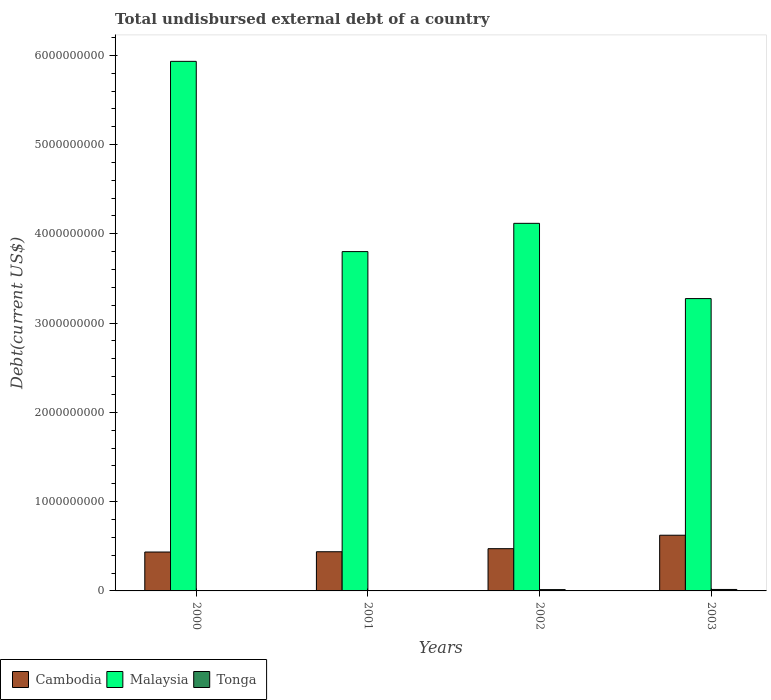How many different coloured bars are there?
Your answer should be compact. 3. Are the number of bars on each tick of the X-axis equal?
Keep it short and to the point. Yes. How many bars are there on the 4th tick from the right?
Ensure brevity in your answer.  3. What is the label of the 1st group of bars from the left?
Provide a short and direct response. 2000. In how many cases, is the number of bars for a given year not equal to the number of legend labels?
Provide a short and direct response. 0. What is the total undisbursed external debt in Tonga in 2000?
Offer a very short reply. 1.98e+06. Across all years, what is the maximum total undisbursed external debt in Cambodia?
Give a very brief answer. 6.24e+08. Across all years, what is the minimum total undisbursed external debt in Cambodia?
Your answer should be compact. 4.36e+08. In which year was the total undisbursed external debt in Tonga minimum?
Provide a short and direct response. 2000. What is the total total undisbursed external debt in Malaysia in the graph?
Your answer should be very brief. 1.71e+1. What is the difference between the total undisbursed external debt in Tonga in 2000 and that in 2002?
Provide a short and direct response. -1.28e+07. What is the difference between the total undisbursed external debt in Malaysia in 2003 and the total undisbursed external debt in Cambodia in 2001?
Your response must be concise. 2.84e+09. What is the average total undisbursed external debt in Malaysia per year?
Keep it short and to the point. 4.28e+09. In the year 2000, what is the difference between the total undisbursed external debt in Cambodia and total undisbursed external debt in Malaysia?
Provide a succinct answer. -5.50e+09. In how many years, is the total undisbursed external debt in Malaysia greater than 1200000000 US$?
Give a very brief answer. 4. What is the ratio of the total undisbursed external debt in Cambodia in 2001 to that in 2003?
Provide a short and direct response. 0.7. Is the difference between the total undisbursed external debt in Cambodia in 2001 and 2002 greater than the difference between the total undisbursed external debt in Malaysia in 2001 and 2002?
Give a very brief answer. Yes. What is the difference between the highest and the second highest total undisbursed external debt in Cambodia?
Your answer should be compact. 1.51e+08. What is the difference between the highest and the lowest total undisbursed external debt in Tonga?
Your answer should be very brief. 1.43e+07. Is the sum of the total undisbursed external debt in Malaysia in 2002 and 2003 greater than the maximum total undisbursed external debt in Tonga across all years?
Offer a very short reply. Yes. What does the 2nd bar from the left in 2001 represents?
Offer a very short reply. Malaysia. What does the 1st bar from the right in 2002 represents?
Make the answer very short. Tonga. How many bars are there?
Give a very brief answer. 12. Are all the bars in the graph horizontal?
Offer a terse response. No. Does the graph contain grids?
Keep it short and to the point. No. How many legend labels are there?
Offer a terse response. 3. How are the legend labels stacked?
Your response must be concise. Horizontal. What is the title of the graph?
Keep it short and to the point. Total undisbursed external debt of a country. Does "Faeroe Islands" appear as one of the legend labels in the graph?
Provide a succinct answer. No. What is the label or title of the Y-axis?
Offer a very short reply. Debt(current US$). What is the Debt(current US$) of Cambodia in 2000?
Your answer should be compact. 4.36e+08. What is the Debt(current US$) of Malaysia in 2000?
Provide a short and direct response. 5.93e+09. What is the Debt(current US$) in Tonga in 2000?
Offer a terse response. 1.98e+06. What is the Debt(current US$) in Cambodia in 2001?
Your answer should be very brief. 4.39e+08. What is the Debt(current US$) of Malaysia in 2001?
Keep it short and to the point. 3.80e+09. What is the Debt(current US$) of Tonga in 2001?
Offer a terse response. 3.44e+06. What is the Debt(current US$) in Cambodia in 2002?
Give a very brief answer. 4.73e+08. What is the Debt(current US$) in Malaysia in 2002?
Provide a short and direct response. 4.12e+09. What is the Debt(current US$) in Tonga in 2002?
Your answer should be compact. 1.48e+07. What is the Debt(current US$) of Cambodia in 2003?
Your answer should be compact. 6.24e+08. What is the Debt(current US$) in Malaysia in 2003?
Make the answer very short. 3.27e+09. What is the Debt(current US$) of Tonga in 2003?
Make the answer very short. 1.63e+07. Across all years, what is the maximum Debt(current US$) in Cambodia?
Your response must be concise. 6.24e+08. Across all years, what is the maximum Debt(current US$) in Malaysia?
Make the answer very short. 5.93e+09. Across all years, what is the maximum Debt(current US$) of Tonga?
Offer a very short reply. 1.63e+07. Across all years, what is the minimum Debt(current US$) in Cambodia?
Keep it short and to the point. 4.36e+08. Across all years, what is the minimum Debt(current US$) of Malaysia?
Provide a succinct answer. 3.27e+09. Across all years, what is the minimum Debt(current US$) in Tonga?
Your response must be concise. 1.98e+06. What is the total Debt(current US$) of Cambodia in the graph?
Your answer should be compact. 1.97e+09. What is the total Debt(current US$) in Malaysia in the graph?
Provide a short and direct response. 1.71e+1. What is the total Debt(current US$) in Tonga in the graph?
Make the answer very short. 3.65e+07. What is the difference between the Debt(current US$) in Cambodia in 2000 and that in 2001?
Give a very brief answer. -3.03e+06. What is the difference between the Debt(current US$) in Malaysia in 2000 and that in 2001?
Keep it short and to the point. 2.13e+09. What is the difference between the Debt(current US$) of Tonga in 2000 and that in 2001?
Keep it short and to the point. -1.46e+06. What is the difference between the Debt(current US$) in Cambodia in 2000 and that in 2002?
Your answer should be compact. -3.74e+07. What is the difference between the Debt(current US$) in Malaysia in 2000 and that in 2002?
Your response must be concise. 1.81e+09. What is the difference between the Debt(current US$) of Tonga in 2000 and that in 2002?
Offer a terse response. -1.28e+07. What is the difference between the Debt(current US$) in Cambodia in 2000 and that in 2003?
Provide a succinct answer. -1.88e+08. What is the difference between the Debt(current US$) in Malaysia in 2000 and that in 2003?
Keep it short and to the point. 2.66e+09. What is the difference between the Debt(current US$) of Tonga in 2000 and that in 2003?
Your answer should be compact. -1.43e+07. What is the difference between the Debt(current US$) of Cambodia in 2001 and that in 2002?
Make the answer very short. -3.44e+07. What is the difference between the Debt(current US$) in Malaysia in 2001 and that in 2002?
Your answer should be compact. -3.17e+08. What is the difference between the Debt(current US$) in Tonga in 2001 and that in 2002?
Your response must be concise. -1.13e+07. What is the difference between the Debt(current US$) of Cambodia in 2001 and that in 2003?
Give a very brief answer. -1.85e+08. What is the difference between the Debt(current US$) of Malaysia in 2001 and that in 2003?
Make the answer very short. 5.26e+08. What is the difference between the Debt(current US$) of Tonga in 2001 and that in 2003?
Provide a succinct answer. -1.29e+07. What is the difference between the Debt(current US$) of Cambodia in 2002 and that in 2003?
Offer a terse response. -1.51e+08. What is the difference between the Debt(current US$) of Malaysia in 2002 and that in 2003?
Offer a very short reply. 8.43e+08. What is the difference between the Debt(current US$) of Tonga in 2002 and that in 2003?
Make the answer very short. -1.53e+06. What is the difference between the Debt(current US$) of Cambodia in 2000 and the Debt(current US$) of Malaysia in 2001?
Provide a short and direct response. -3.37e+09. What is the difference between the Debt(current US$) of Cambodia in 2000 and the Debt(current US$) of Tonga in 2001?
Your response must be concise. 4.32e+08. What is the difference between the Debt(current US$) in Malaysia in 2000 and the Debt(current US$) in Tonga in 2001?
Keep it short and to the point. 5.93e+09. What is the difference between the Debt(current US$) in Cambodia in 2000 and the Debt(current US$) in Malaysia in 2002?
Ensure brevity in your answer.  -3.68e+09. What is the difference between the Debt(current US$) in Cambodia in 2000 and the Debt(current US$) in Tonga in 2002?
Your response must be concise. 4.21e+08. What is the difference between the Debt(current US$) in Malaysia in 2000 and the Debt(current US$) in Tonga in 2002?
Offer a terse response. 5.92e+09. What is the difference between the Debt(current US$) in Cambodia in 2000 and the Debt(current US$) in Malaysia in 2003?
Provide a succinct answer. -2.84e+09. What is the difference between the Debt(current US$) of Cambodia in 2000 and the Debt(current US$) of Tonga in 2003?
Your answer should be compact. 4.20e+08. What is the difference between the Debt(current US$) in Malaysia in 2000 and the Debt(current US$) in Tonga in 2003?
Provide a short and direct response. 5.92e+09. What is the difference between the Debt(current US$) in Cambodia in 2001 and the Debt(current US$) in Malaysia in 2002?
Give a very brief answer. -3.68e+09. What is the difference between the Debt(current US$) of Cambodia in 2001 and the Debt(current US$) of Tonga in 2002?
Give a very brief answer. 4.24e+08. What is the difference between the Debt(current US$) of Malaysia in 2001 and the Debt(current US$) of Tonga in 2002?
Make the answer very short. 3.79e+09. What is the difference between the Debt(current US$) of Cambodia in 2001 and the Debt(current US$) of Malaysia in 2003?
Provide a succinct answer. -2.84e+09. What is the difference between the Debt(current US$) in Cambodia in 2001 and the Debt(current US$) in Tonga in 2003?
Offer a very short reply. 4.23e+08. What is the difference between the Debt(current US$) of Malaysia in 2001 and the Debt(current US$) of Tonga in 2003?
Make the answer very short. 3.78e+09. What is the difference between the Debt(current US$) in Cambodia in 2002 and the Debt(current US$) in Malaysia in 2003?
Your answer should be very brief. -2.80e+09. What is the difference between the Debt(current US$) of Cambodia in 2002 and the Debt(current US$) of Tonga in 2003?
Offer a terse response. 4.57e+08. What is the difference between the Debt(current US$) in Malaysia in 2002 and the Debt(current US$) in Tonga in 2003?
Provide a succinct answer. 4.10e+09. What is the average Debt(current US$) of Cambodia per year?
Offer a very short reply. 4.93e+08. What is the average Debt(current US$) of Malaysia per year?
Make the answer very short. 4.28e+09. What is the average Debt(current US$) in Tonga per year?
Keep it short and to the point. 9.12e+06. In the year 2000, what is the difference between the Debt(current US$) of Cambodia and Debt(current US$) of Malaysia?
Ensure brevity in your answer.  -5.50e+09. In the year 2000, what is the difference between the Debt(current US$) in Cambodia and Debt(current US$) in Tonga?
Offer a very short reply. 4.34e+08. In the year 2000, what is the difference between the Debt(current US$) in Malaysia and Debt(current US$) in Tonga?
Your answer should be compact. 5.93e+09. In the year 2001, what is the difference between the Debt(current US$) in Cambodia and Debt(current US$) in Malaysia?
Offer a terse response. -3.36e+09. In the year 2001, what is the difference between the Debt(current US$) of Cambodia and Debt(current US$) of Tonga?
Your answer should be compact. 4.35e+08. In the year 2001, what is the difference between the Debt(current US$) in Malaysia and Debt(current US$) in Tonga?
Make the answer very short. 3.80e+09. In the year 2002, what is the difference between the Debt(current US$) of Cambodia and Debt(current US$) of Malaysia?
Give a very brief answer. -3.64e+09. In the year 2002, what is the difference between the Debt(current US$) of Cambodia and Debt(current US$) of Tonga?
Provide a succinct answer. 4.58e+08. In the year 2002, what is the difference between the Debt(current US$) of Malaysia and Debt(current US$) of Tonga?
Your answer should be very brief. 4.10e+09. In the year 2003, what is the difference between the Debt(current US$) of Cambodia and Debt(current US$) of Malaysia?
Offer a terse response. -2.65e+09. In the year 2003, what is the difference between the Debt(current US$) in Cambodia and Debt(current US$) in Tonga?
Your response must be concise. 6.08e+08. In the year 2003, what is the difference between the Debt(current US$) of Malaysia and Debt(current US$) of Tonga?
Your response must be concise. 3.26e+09. What is the ratio of the Debt(current US$) of Cambodia in 2000 to that in 2001?
Provide a short and direct response. 0.99. What is the ratio of the Debt(current US$) in Malaysia in 2000 to that in 2001?
Keep it short and to the point. 1.56. What is the ratio of the Debt(current US$) in Tonga in 2000 to that in 2001?
Your response must be concise. 0.57. What is the ratio of the Debt(current US$) in Cambodia in 2000 to that in 2002?
Your response must be concise. 0.92. What is the ratio of the Debt(current US$) in Malaysia in 2000 to that in 2002?
Your answer should be very brief. 1.44. What is the ratio of the Debt(current US$) in Tonga in 2000 to that in 2002?
Give a very brief answer. 0.13. What is the ratio of the Debt(current US$) of Cambodia in 2000 to that in 2003?
Ensure brevity in your answer.  0.7. What is the ratio of the Debt(current US$) of Malaysia in 2000 to that in 2003?
Your answer should be very brief. 1.81. What is the ratio of the Debt(current US$) of Tonga in 2000 to that in 2003?
Your answer should be very brief. 0.12. What is the ratio of the Debt(current US$) of Cambodia in 2001 to that in 2002?
Ensure brevity in your answer.  0.93. What is the ratio of the Debt(current US$) in Malaysia in 2001 to that in 2002?
Offer a very short reply. 0.92. What is the ratio of the Debt(current US$) of Tonga in 2001 to that in 2002?
Your response must be concise. 0.23. What is the ratio of the Debt(current US$) of Cambodia in 2001 to that in 2003?
Ensure brevity in your answer.  0.7. What is the ratio of the Debt(current US$) of Malaysia in 2001 to that in 2003?
Your answer should be very brief. 1.16. What is the ratio of the Debt(current US$) of Tonga in 2001 to that in 2003?
Ensure brevity in your answer.  0.21. What is the ratio of the Debt(current US$) of Cambodia in 2002 to that in 2003?
Keep it short and to the point. 0.76. What is the ratio of the Debt(current US$) in Malaysia in 2002 to that in 2003?
Offer a very short reply. 1.26. What is the ratio of the Debt(current US$) in Tonga in 2002 to that in 2003?
Provide a short and direct response. 0.91. What is the difference between the highest and the second highest Debt(current US$) in Cambodia?
Make the answer very short. 1.51e+08. What is the difference between the highest and the second highest Debt(current US$) of Malaysia?
Offer a terse response. 1.81e+09. What is the difference between the highest and the second highest Debt(current US$) in Tonga?
Give a very brief answer. 1.53e+06. What is the difference between the highest and the lowest Debt(current US$) of Cambodia?
Make the answer very short. 1.88e+08. What is the difference between the highest and the lowest Debt(current US$) of Malaysia?
Make the answer very short. 2.66e+09. What is the difference between the highest and the lowest Debt(current US$) in Tonga?
Ensure brevity in your answer.  1.43e+07. 